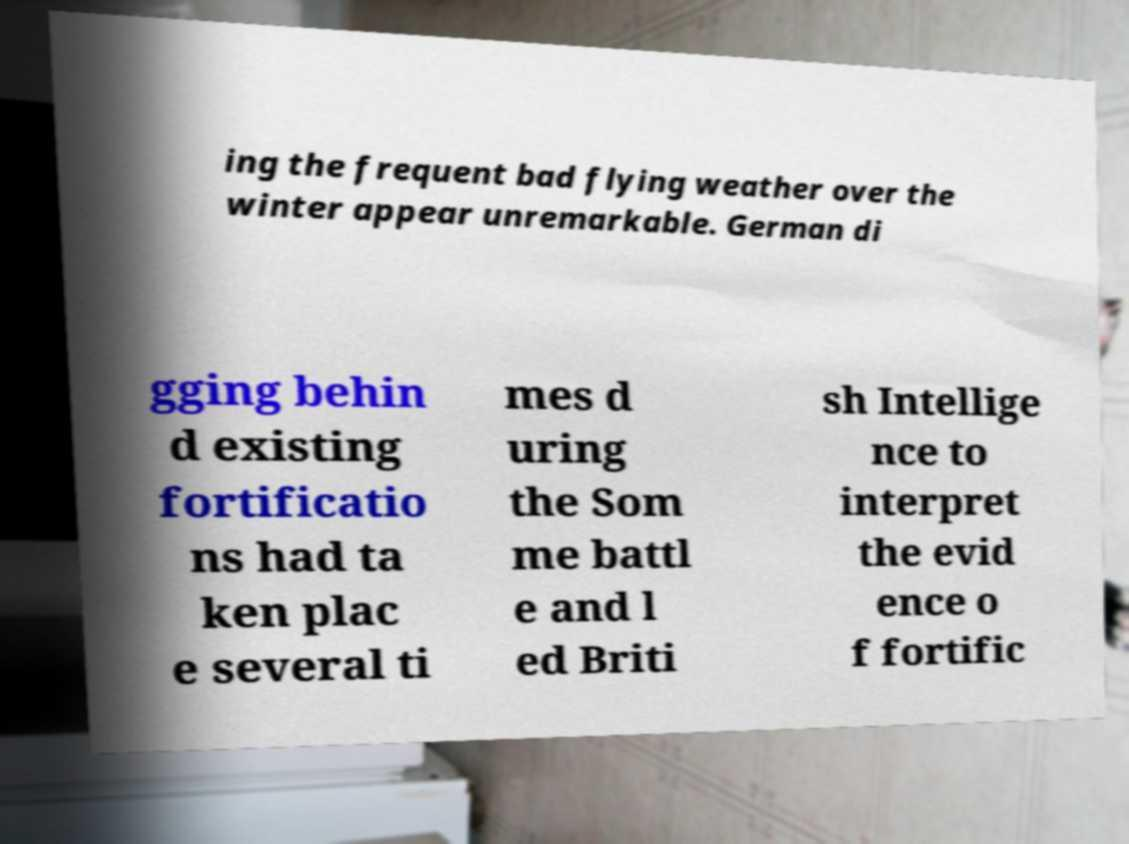Can you accurately transcribe the text from the provided image for me? ing the frequent bad flying weather over the winter appear unremarkable. German di gging behin d existing fortificatio ns had ta ken plac e several ti mes d uring the Som me battl e and l ed Briti sh Intellige nce to interpret the evid ence o f fortific 